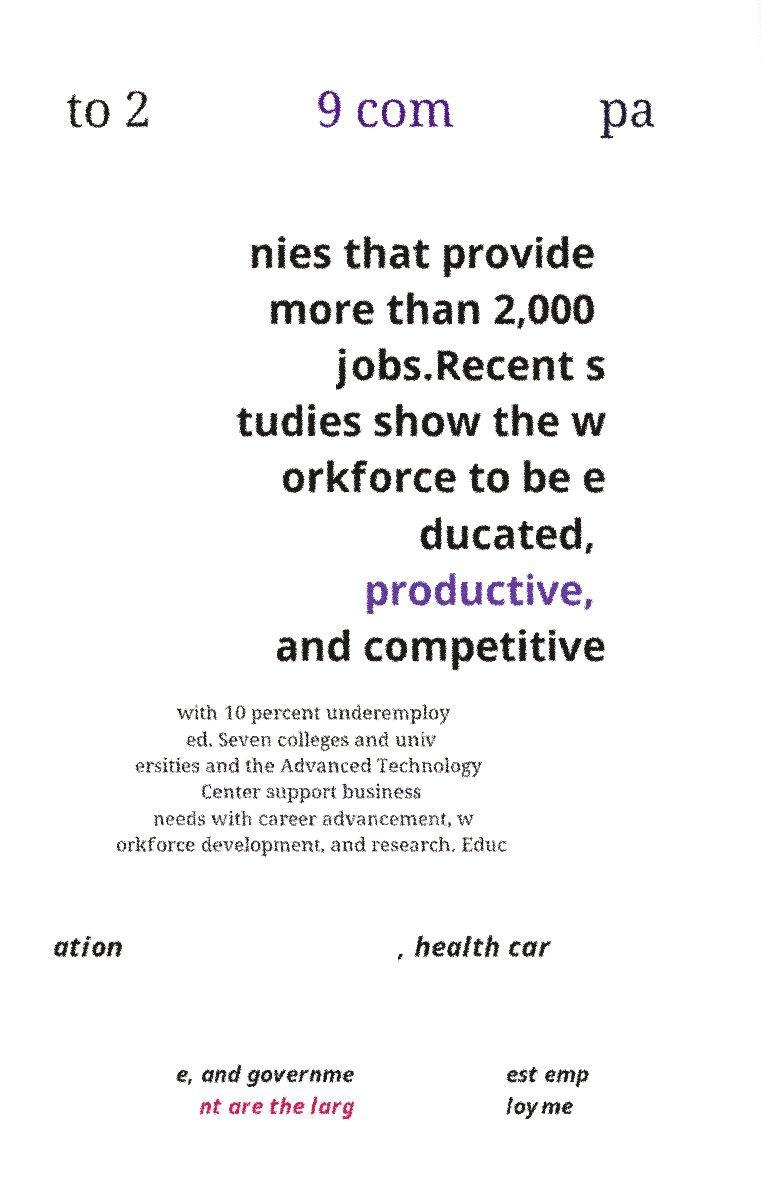Please identify and transcribe the text found in this image. to 2 9 com pa nies that provide more than 2,000 jobs.Recent s tudies show the w orkforce to be e ducated, productive, and competitive with 10 percent underemploy ed. Seven colleges and univ ersities and the Advanced Technology Center support business needs with career advancement, w orkforce development, and research. Educ ation , health car e, and governme nt are the larg est emp loyme 